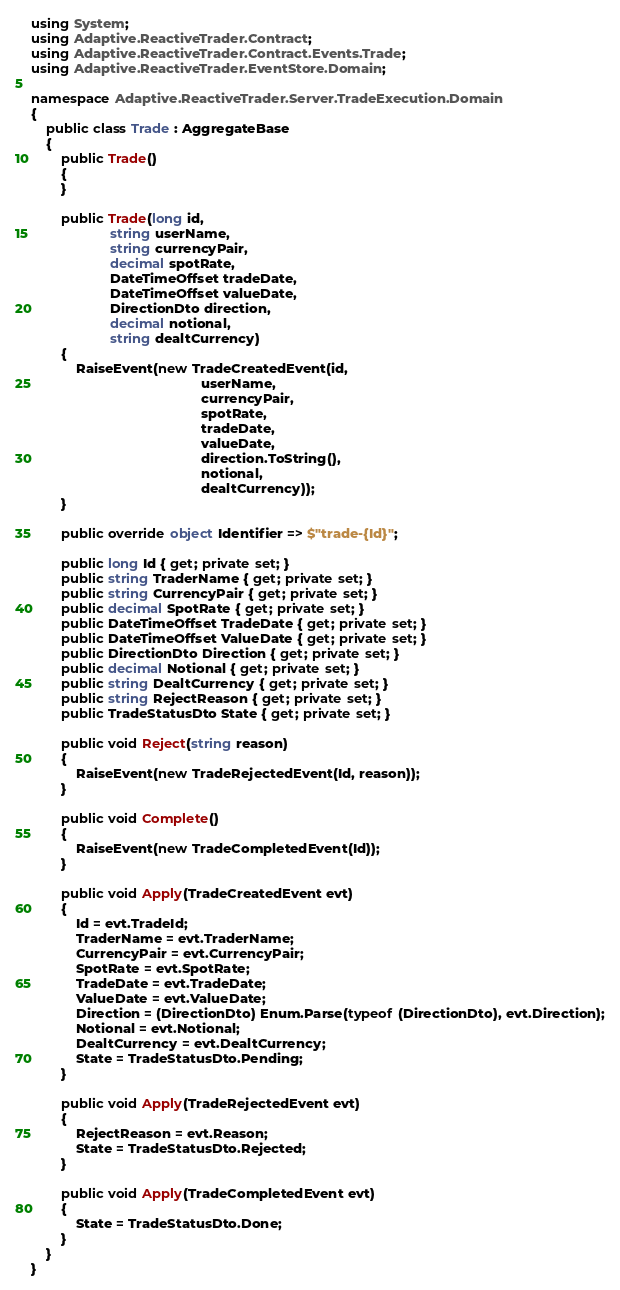<code> <loc_0><loc_0><loc_500><loc_500><_C#_>using System;
using Adaptive.ReactiveTrader.Contract;
using Adaptive.ReactiveTrader.Contract.Events.Trade;
using Adaptive.ReactiveTrader.EventStore.Domain;

namespace Adaptive.ReactiveTrader.Server.TradeExecution.Domain
{
    public class Trade : AggregateBase
    {
        public Trade()
        {
        }

        public Trade(long id,
                     string userName,
                     string currencyPair,
                     decimal spotRate,
                     DateTimeOffset tradeDate,
                     DateTimeOffset valueDate,
                     DirectionDto direction,
                     decimal notional,
                     string dealtCurrency)
        {
            RaiseEvent(new TradeCreatedEvent(id,
                                             userName,
                                             currencyPair,
                                             spotRate,
                                             tradeDate,
                                             valueDate,
                                             direction.ToString(),
                                             notional,
                                             dealtCurrency));
        }

        public override object Identifier => $"trade-{Id}";

        public long Id { get; private set; }
        public string TraderName { get; private set; }
        public string CurrencyPair { get; private set; }
        public decimal SpotRate { get; private set; }
        public DateTimeOffset TradeDate { get; private set; }
        public DateTimeOffset ValueDate { get; private set; }
        public DirectionDto Direction { get; private set; }
        public decimal Notional { get; private set; }
        public string DealtCurrency { get; private set; }
        public string RejectReason { get; private set; }
        public TradeStatusDto State { get; private set; }

        public void Reject(string reason)
        {
            RaiseEvent(new TradeRejectedEvent(Id, reason));
        }

        public void Complete()
        {
            RaiseEvent(new TradeCompletedEvent(Id));
        }

        public void Apply(TradeCreatedEvent evt)
        {
            Id = evt.TradeId;
            TraderName = evt.TraderName;
            CurrencyPair = evt.CurrencyPair;
            SpotRate = evt.SpotRate;
            TradeDate = evt.TradeDate;
            ValueDate = evt.ValueDate;
            Direction = (DirectionDto) Enum.Parse(typeof (DirectionDto), evt.Direction);
            Notional = evt.Notional;
            DealtCurrency = evt.DealtCurrency;
            State = TradeStatusDto.Pending;
        }

        public void Apply(TradeRejectedEvent evt)
        {
            RejectReason = evt.Reason;
            State = TradeStatusDto.Rejected;
        }

        public void Apply(TradeCompletedEvent evt)
        {
            State = TradeStatusDto.Done;
        }
    }
}
</code> 